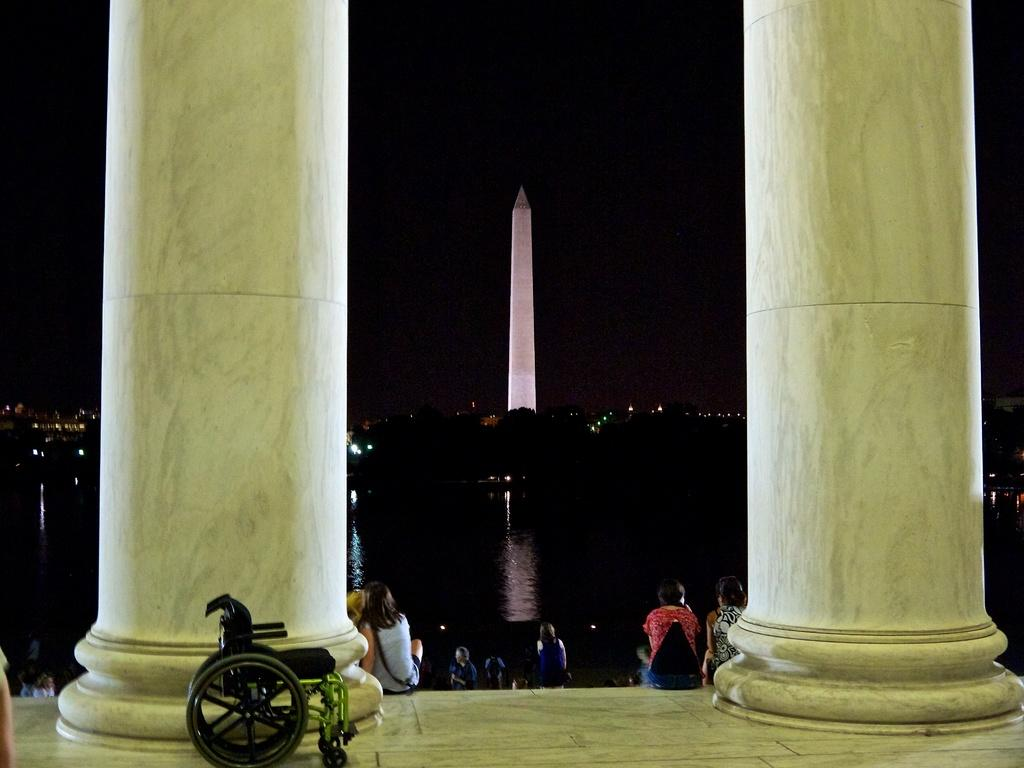What are the people in the image doing? The people in the image are sitting on chairs and standing on the floor. What can be seen in the background of the image? There is water, trees, a tower, and the sky visible in the image. What type of lighting is present in the image? Electric lights are present in the image. Is there any special equipment visible in the image? Yes, a wheelchair is visible in the image. What type of debt is being discussed in the image? There is no mention or indication of any debt being discussed in the image. What type of frame surrounds the image? The image does not have a frame; it is a photograph or digital image without a physical border. 